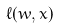<formula> <loc_0><loc_0><loc_500><loc_500>\ell ( w , x )</formula> 